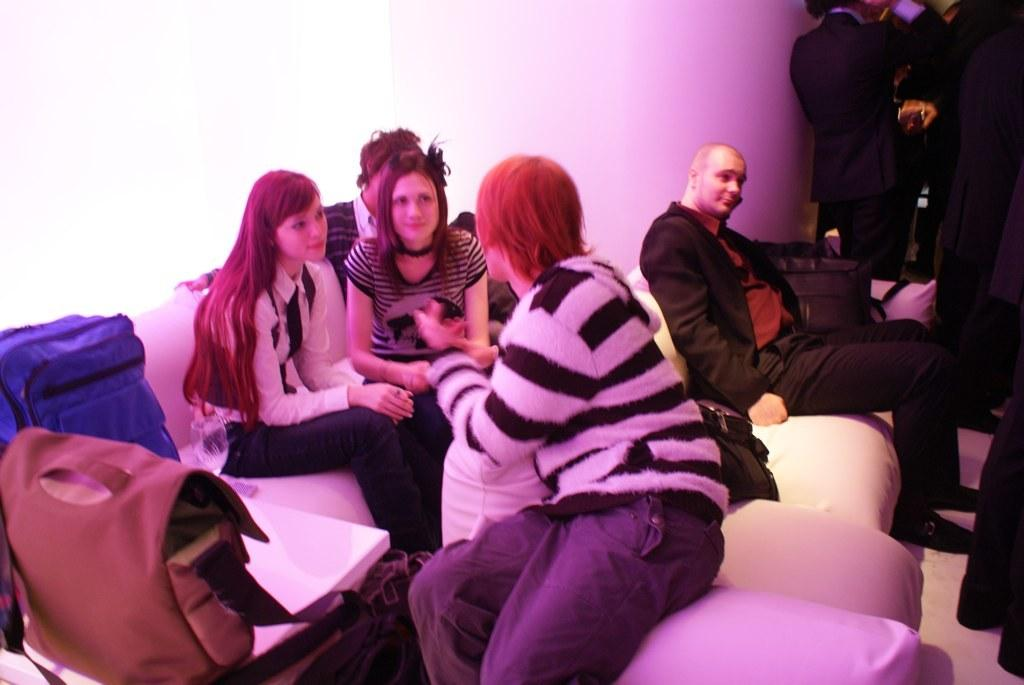What are the people in the image doing? The people in the image are sitting on couches. What are the people sitting on couches holding? The people on the couches have bags. Are there any people standing in the image? Yes, there are people standing in the right side corner of the image. What fact can be observed about the middle of the image? There is no specific fact about the middle of the image mentioned in the provided facts. 